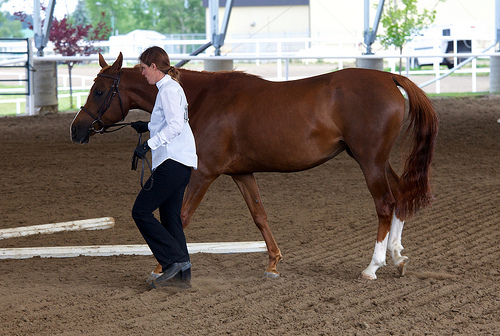<image>
Is there a horse behind the woman? Yes. From this viewpoint, the horse is positioned behind the woman, with the woman partially or fully occluding the horse. 